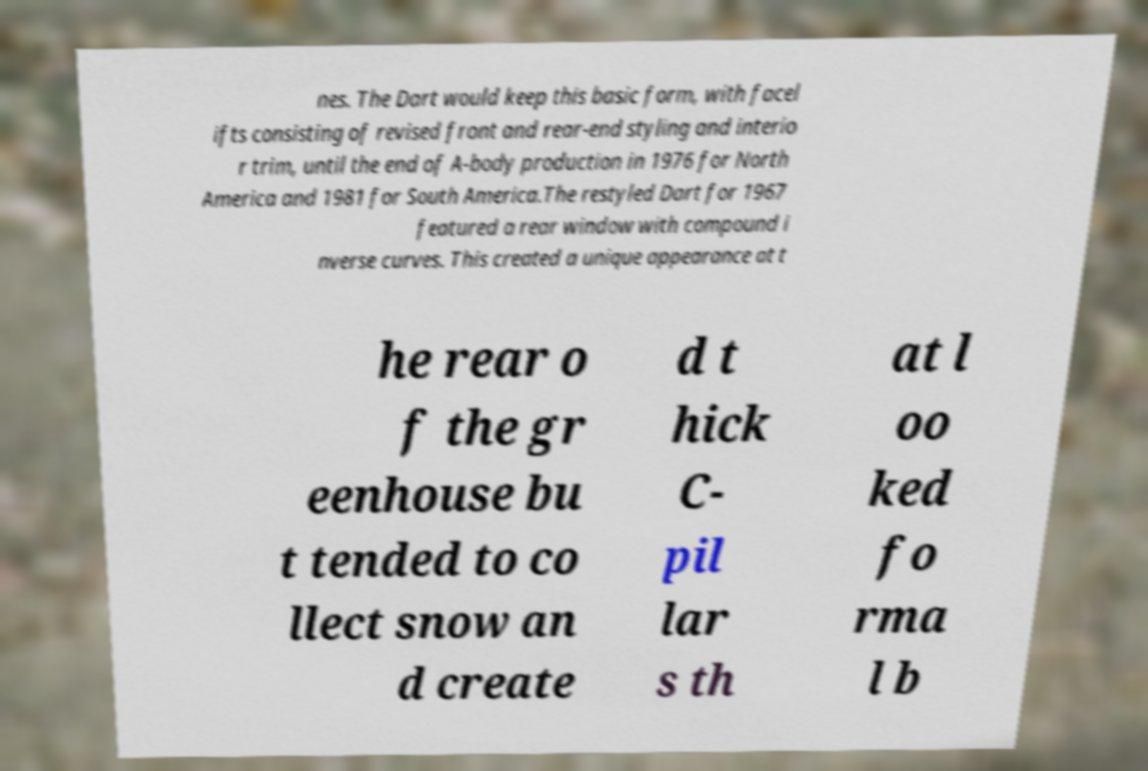Could you extract and type out the text from this image? nes. The Dart would keep this basic form, with facel ifts consisting of revised front and rear-end styling and interio r trim, until the end of A-body production in 1976 for North America and 1981 for South America.The restyled Dart for 1967 featured a rear window with compound i nverse curves. This created a unique appearance at t he rear o f the gr eenhouse bu t tended to co llect snow an d create d t hick C- pil lar s th at l oo ked fo rma l b 